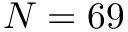<formula> <loc_0><loc_0><loc_500><loc_500>N = 6 9</formula> 